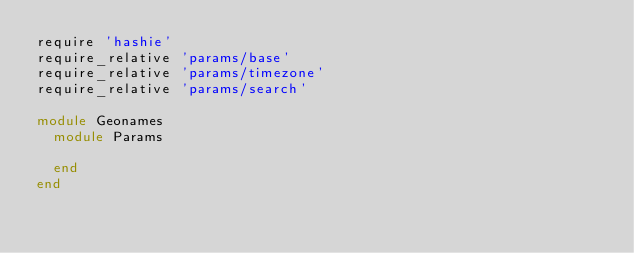Convert code to text. <code><loc_0><loc_0><loc_500><loc_500><_Ruby_>require 'hashie'
require_relative 'params/base'
require_relative 'params/timezone'
require_relative 'params/search'

module Geonames
  module Params

  end
end
</code> 